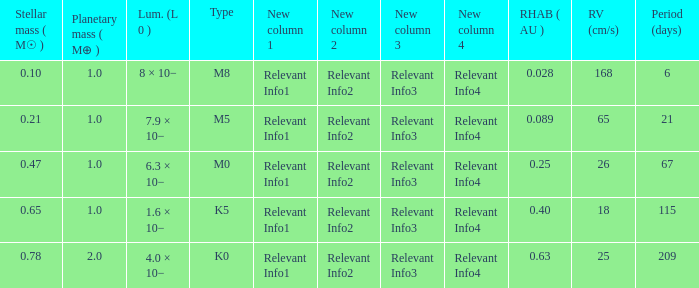What is the total stellar mass of the type m0? 0.47. 